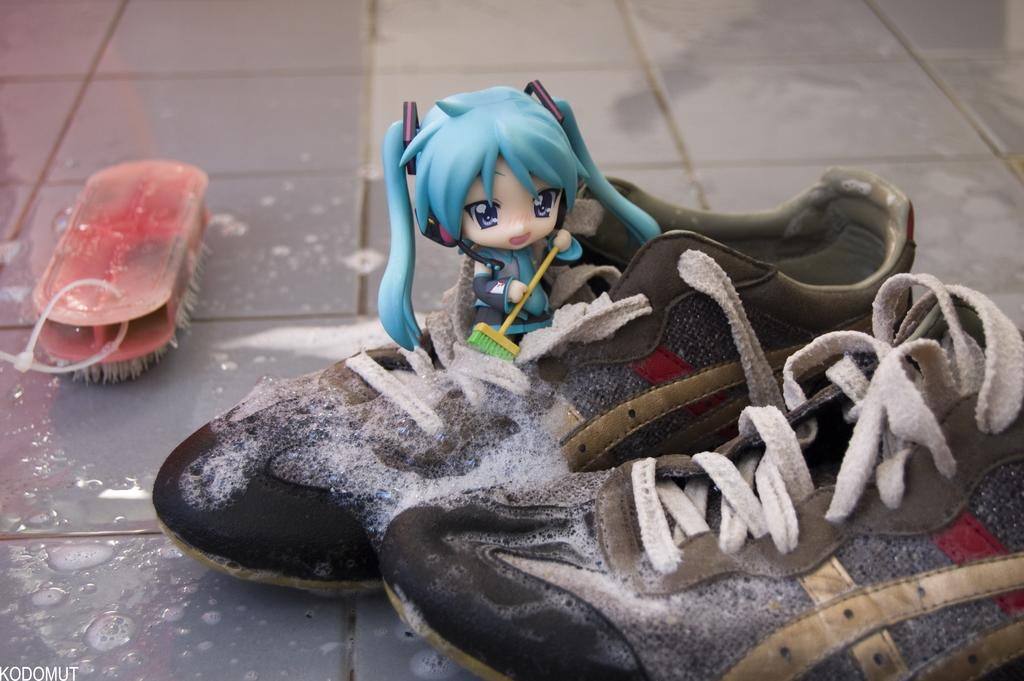What objects are present in the image? There are shoes and a toy in the image. How is the toy positioned in relation to the shoes? The toy is placed on one of the shoes. What is covering the shoes? There is foam on the shoes. What can be seen on the left side of the image? There is a brush on the left side of the image. What is written or depicted in the bottom left corner of the image? There is text in the bottom left corner of the image. What is the father doing with his knee in the image? There is no father or knee present in the image. How does the elbow of the person in the image look like? There is no person or elbow present in the image. 